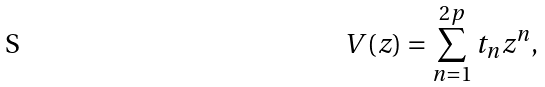Convert formula to latex. <formula><loc_0><loc_0><loc_500><loc_500>V ( z ) = \sum _ { n = 1 } ^ { 2 p } t _ { n } z ^ { n } ,</formula> 